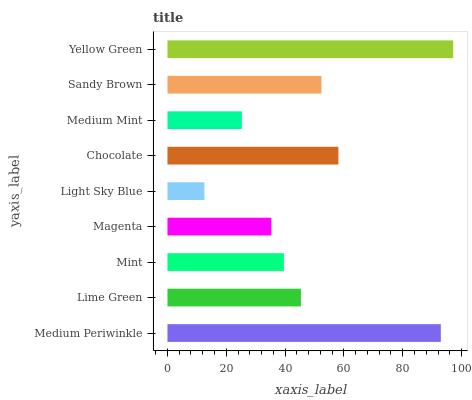Is Light Sky Blue the minimum?
Answer yes or no. Yes. Is Yellow Green the maximum?
Answer yes or no. Yes. Is Lime Green the minimum?
Answer yes or no. No. Is Lime Green the maximum?
Answer yes or no. No. Is Medium Periwinkle greater than Lime Green?
Answer yes or no. Yes. Is Lime Green less than Medium Periwinkle?
Answer yes or no. Yes. Is Lime Green greater than Medium Periwinkle?
Answer yes or no. No. Is Medium Periwinkle less than Lime Green?
Answer yes or no. No. Is Lime Green the high median?
Answer yes or no. Yes. Is Lime Green the low median?
Answer yes or no. Yes. Is Chocolate the high median?
Answer yes or no. No. Is Light Sky Blue the low median?
Answer yes or no. No. 